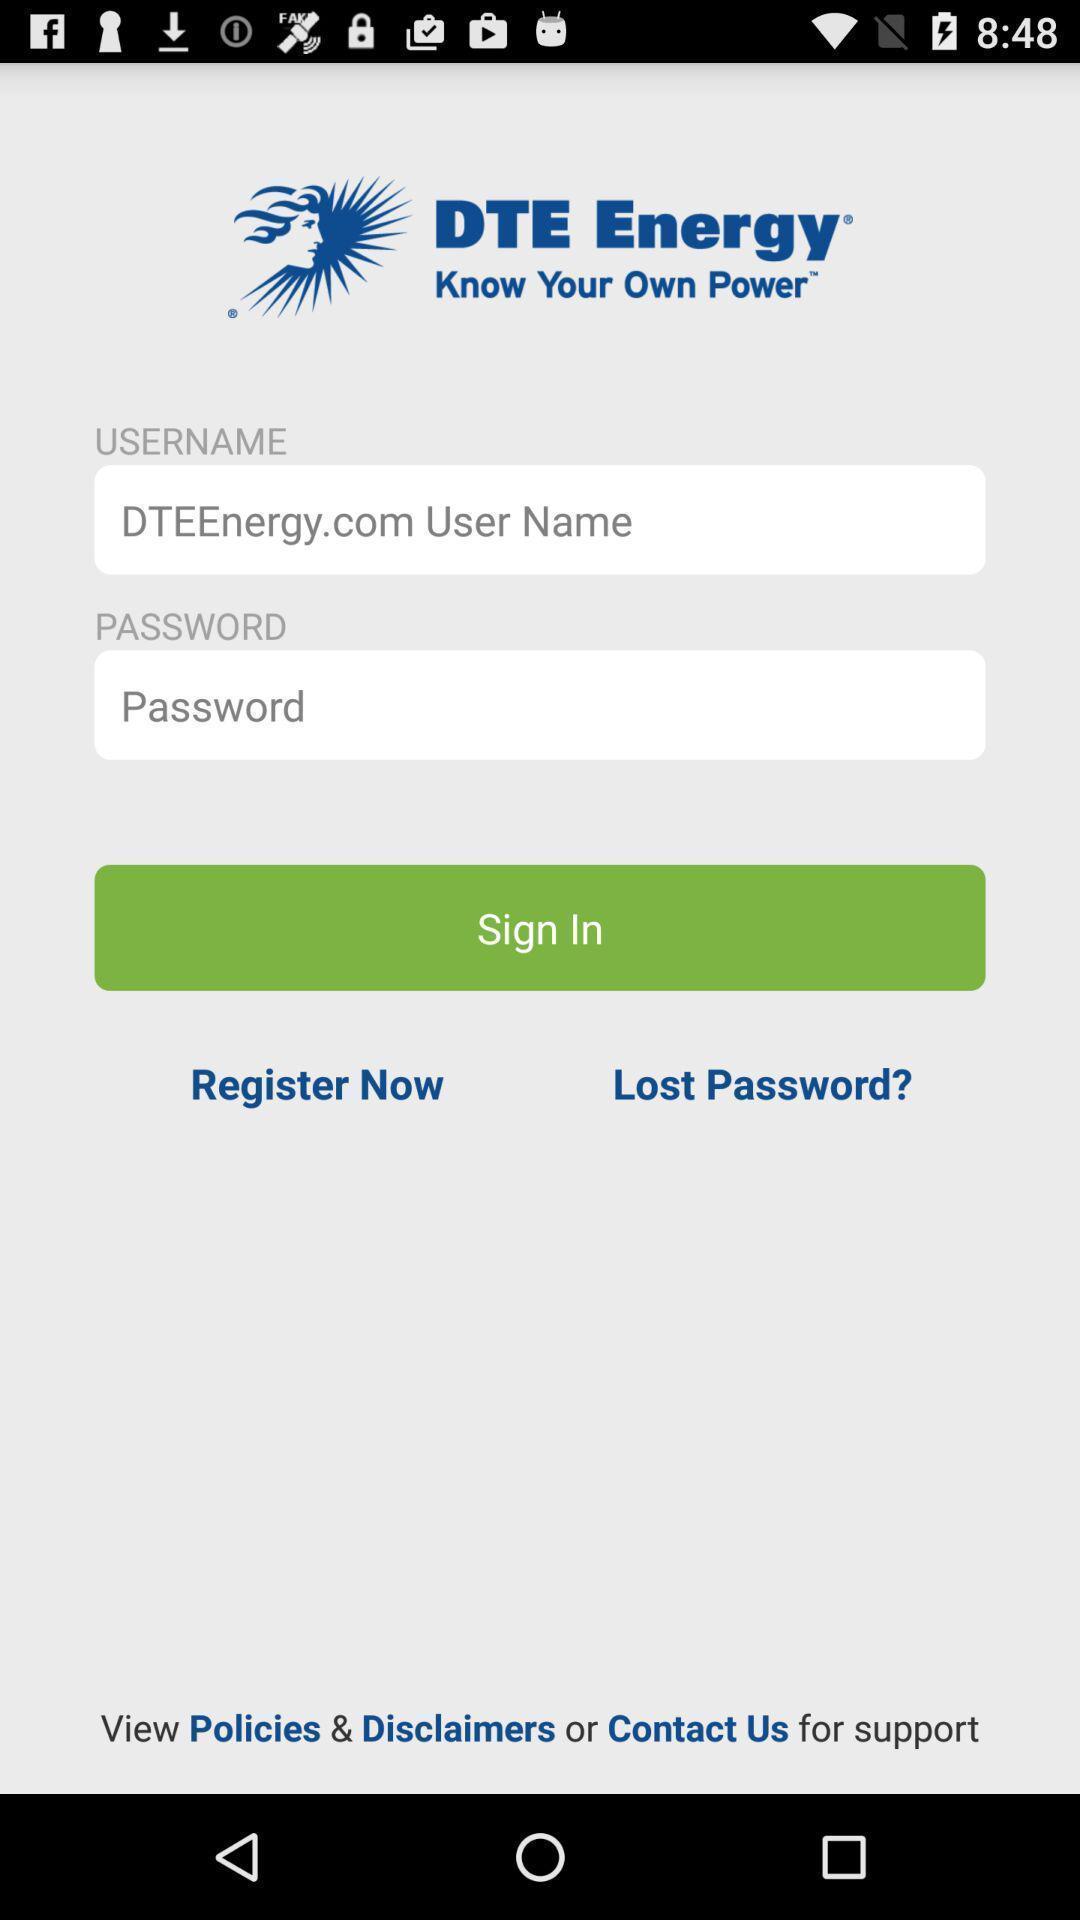Describe the content in this image. Welcome to the sign in page. 